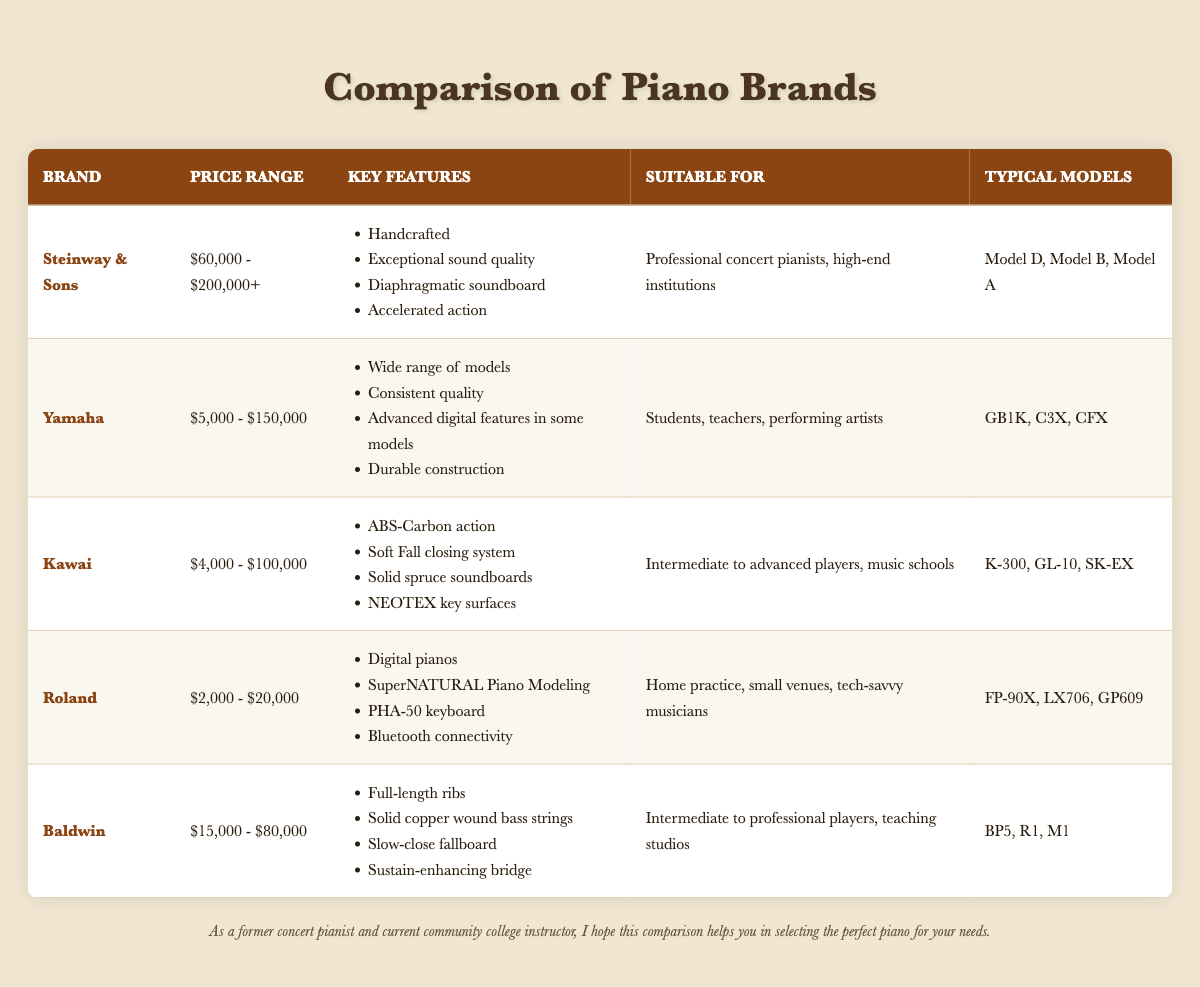What is the highest price range among the piano brands listed? The highest price range listed is for Steinway & Sons, which is "$60,000 - $200,000+".
Answer: $60,000 - $200,000+ Which piano brand offers digital features in some of its models? Yamaha offers advanced digital features in some models, as indicated in the key features column.
Answer: Yamaha What are the typical models for Kawai? The typical models for Kawai are listed in the table as K-300, GL-10, and SK-EX.
Answer: K-300, GL-10, SK-EX How many brands have a price range below $10,000? Only Roland has a price range below $10,000, specifically between $2,000 and $20,000.
Answer: 1 Is it true that Baldwin pianos have a slow-close fallboard? Yes, the key features for Baldwin state that it has a slow-close fallboard.
Answer: Yes What is the price range for Yamaha compared to Kawai? Yamaha’s price range is $5,000 - $150,000, while Kawai’s price range is $4,000 - $100,000. Yamaha's upper limit is higher than Kawai's, indicating more expensive models.
Answer: Yamaha's price range is higher than Kawai's Which brand is suitable for tech-savvy musicians? Roland is listed as suitable for tech-savvy musicians, indicated in the suitable for column.
Answer: Roland What percentage of the listed brands are suitable for professional concert pianists? Only Steinway & Sons and Baldwin are explicitly suitable for professional concert pianists. Out of five brands listed, this constitutes 2 out of 5 or 40%.
Answer: 40% Which two brands share a common suitability for intermediate to advanced players? Kawai and Baldwin are both suitable for intermediate to advanced players, as indicated in the suitability section.
Answer: Kawai and Baldwin 